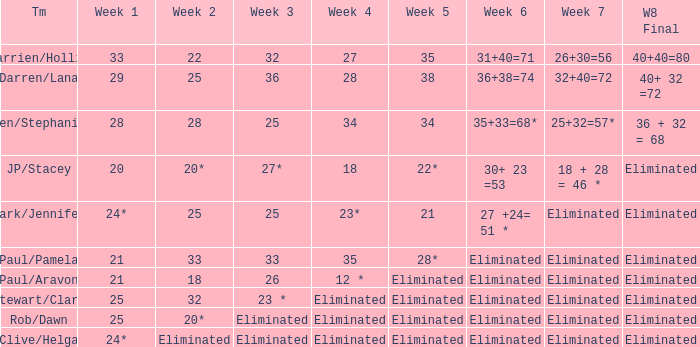Name the week 3 of 36 29.0. 